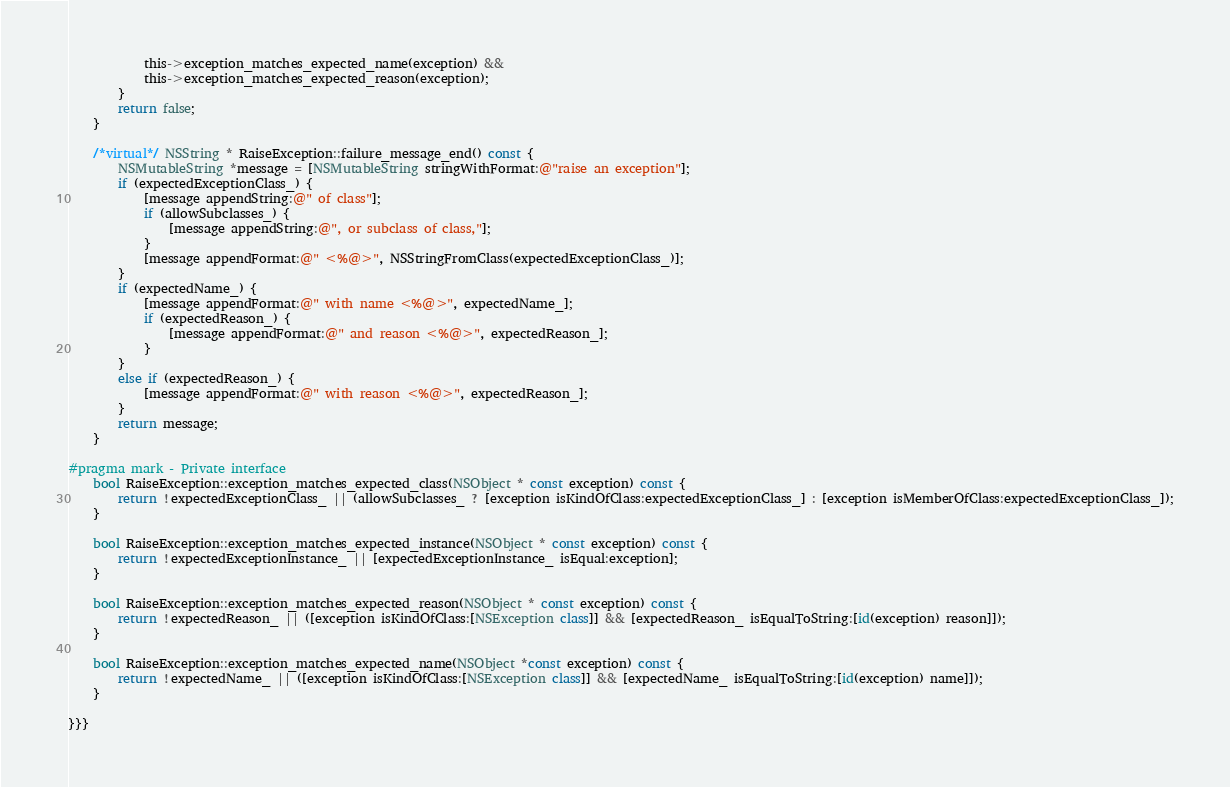<code> <loc_0><loc_0><loc_500><loc_500><_ObjectiveC_>            this->exception_matches_expected_name(exception) &&
            this->exception_matches_expected_reason(exception);
        }
        return false;
    }

    /*virtual*/ NSString * RaiseException::failure_message_end() const {
        NSMutableString *message = [NSMutableString stringWithFormat:@"raise an exception"];
        if (expectedExceptionClass_) {
            [message appendString:@" of class"];
            if (allowSubclasses_) {
                [message appendString:@", or subclass of class,"];
            }
            [message appendFormat:@" <%@>", NSStringFromClass(expectedExceptionClass_)];
        }
        if (expectedName_) {
            [message appendFormat:@" with name <%@>", expectedName_];
            if (expectedReason_) {
                [message appendFormat:@" and reason <%@>", expectedReason_];
            }
        }
        else if (expectedReason_) {
            [message appendFormat:@" with reason <%@>", expectedReason_];
        }
        return message;
    }

#pragma mark - Private interface
    bool RaiseException::exception_matches_expected_class(NSObject * const exception) const {
        return !expectedExceptionClass_ || (allowSubclasses_ ? [exception isKindOfClass:expectedExceptionClass_] : [exception isMemberOfClass:expectedExceptionClass_]);
    }

    bool RaiseException::exception_matches_expected_instance(NSObject * const exception) const {
        return !expectedExceptionInstance_ || [expectedExceptionInstance_ isEqual:exception];
    }

    bool RaiseException::exception_matches_expected_reason(NSObject * const exception) const {
        return !expectedReason_ || ([exception isKindOfClass:[NSException class]] && [expectedReason_ isEqualToString:[id(exception) reason]]);
    }

    bool RaiseException::exception_matches_expected_name(NSObject *const exception) const {
        return !expectedName_ || ([exception isKindOfClass:[NSException class]] && [expectedName_ isEqualToString:[id(exception) name]]);
    }

}}}
</code> 